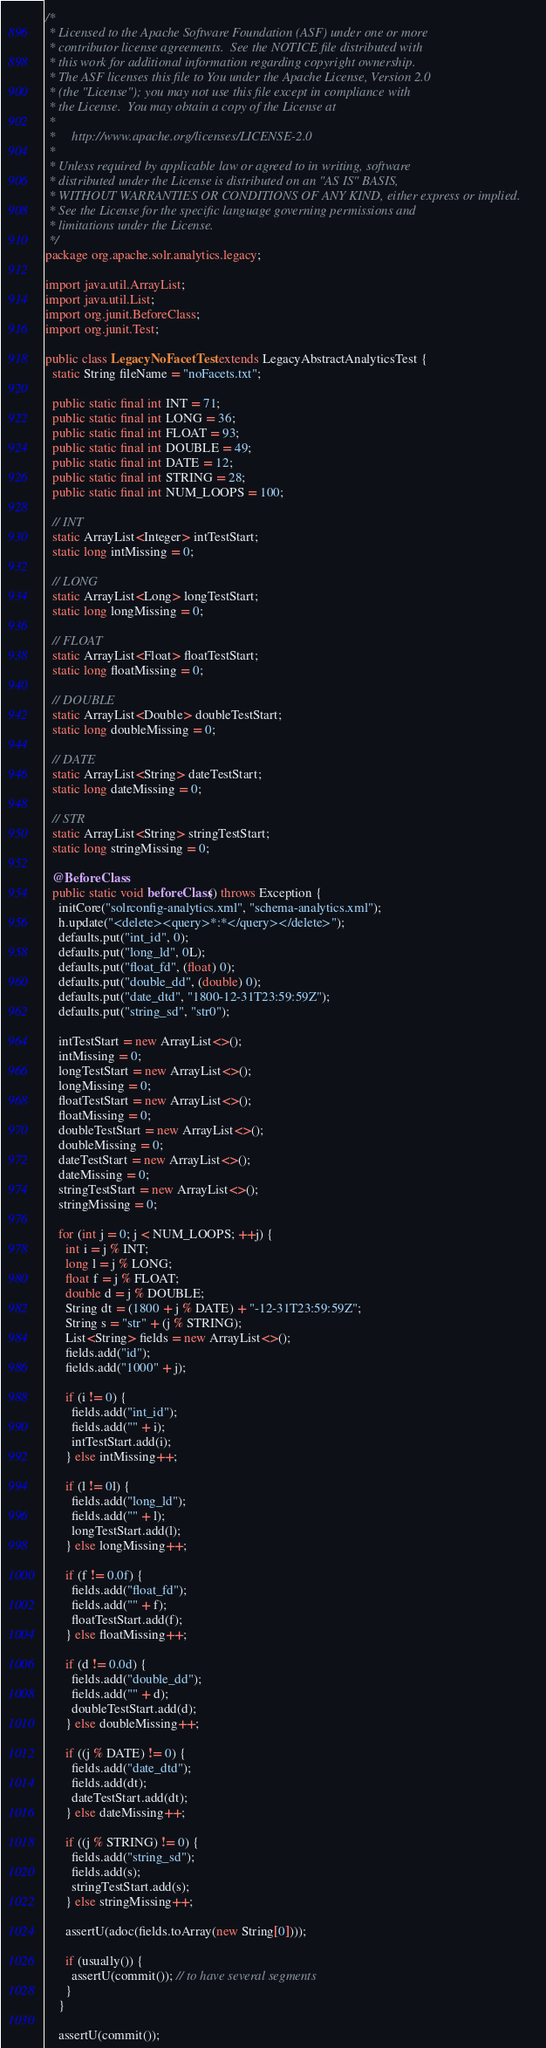Convert code to text. <code><loc_0><loc_0><loc_500><loc_500><_Java_>/*
 * Licensed to the Apache Software Foundation (ASF) under one or more
 * contributor license agreements.  See the NOTICE file distributed with
 * this work for additional information regarding copyright ownership.
 * The ASF licenses this file to You under the Apache License, Version 2.0
 * (the "License"); you may not use this file except in compliance with
 * the License.  You may obtain a copy of the License at
 *
 *     http://www.apache.org/licenses/LICENSE-2.0
 *
 * Unless required by applicable law or agreed to in writing, software
 * distributed under the License is distributed on an "AS IS" BASIS,
 * WITHOUT WARRANTIES OR CONDITIONS OF ANY KIND, either express or implied.
 * See the License for the specific language governing permissions and
 * limitations under the License.
 */
package org.apache.solr.analytics.legacy;

import java.util.ArrayList;
import java.util.List;
import org.junit.BeforeClass;
import org.junit.Test;

public class LegacyNoFacetTest extends LegacyAbstractAnalyticsTest {
  static String fileName = "noFacets.txt";

  public static final int INT = 71;
  public static final int LONG = 36;
  public static final int FLOAT = 93;
  public static final int DOUBLE = 49;
  public static final int DATE = 12;
  public static final int STRING = 28;
  public static final int NUM_LOOPS = 100;

  // INT
  static ArrayList<Integer> intTestStart;
  static long intMissing = 0;

  // LONG
  static ArrayList<Long> longTestStart;
  static long longMissing = 0;

  // FLOAT
  static ArrayList<Float> floatTestStart;
  static long floatMissing = 0;

  // DOUBLE
  static ArrayList<Double> doubleTestStart;
  static long doubleMissing = 0;

  // DATE
  static ArrayList<String> dateTestStart;
  static long dateMissing = 0;

  // STR
  static ArrayList<String> stringTestStart;
  static long stringMissing = 0;

  @BeforeClass
  public static void beforeClass() throws Exception {
    initCore("solrconfig-analytics.xml", "schema-analytics.xml");
    h.update("<delete><query>*:*</query></delete>");
    defaults.put("int_id", 0);
    defaults.put("long_ld", 0L);
    defaults.put("float_fd", (float) 0);
    defaults.put("double_dd", (double) 0);
    defaults.put("date_dtd", "1800-12-31T23:59:59Z");
    defaults.put("string_sd", "str0");

    intTestStart = new ArrayList<>();
    intMissing = 0;
    longTestStart = new ArrayList<>();
    longMissing = 0;
    floatTestStart = new ArrayList<>();
    floatMissing = 0;
    doubleTestStart = new ArrayList<>();
    doubleMissing = 0;
    dateTestStart = new ArrayList<>();
    dateMissing = 0;
    stringTestStart = new ArrayList<>();
    stringMissing = 0;

    for (int j = 0; j < NUM_LOOPS; ++j) {
      int i = j % INT;
      long l = j % LONG;
      float f = j % FLOAT;
      double d = j % DOUBLE;
      String dt = (1800 + j % DATE) + "-12-31T23:59:59Z";
      String s = "str" + (j % STRING);
      List<String> fields = new ArrayList<>();
      fields.add("id");
      fields.add("1000" + j);

      if (i != 0) {
        fields.add("int_id");
        fields.add("" + i);
        intTestStart.add(i);
      } else intMissing++;

      if (l != 0l) {
        fields.add("long_ld");
        fields.add("" + l);
        longTestStart.add(l);
      } else longMissing++;

      if (f != 0.0f) {
        fields.add("float_fd");
        fields.add("" + f);
        floatTestStart.add(f);
      } else floatMissing++;

      if (d != 0.0d) {
        fields.add("double_dd");
        fields.add("" + d);
        doubleTestStart.add(d);
      } else doubleMissing++;

      if ((j % DATE) != 0) {
        fields.add("date_dtd");
        fields.add(dt);
        dateTestStart.add(dt);
      } else dateMissing++;

      if ((j % STRING) != 0) {
        fields.add("string_sd");
        fields.add(s);
        stringTestStart.add(s);
      } else stringMissing++;

      assertU(adoc(fields.toArray(new String[0])));

      if (usually()) {
        assertU(commit()); // to have several segments
      }
    }

    assertU(commit());
</code> 